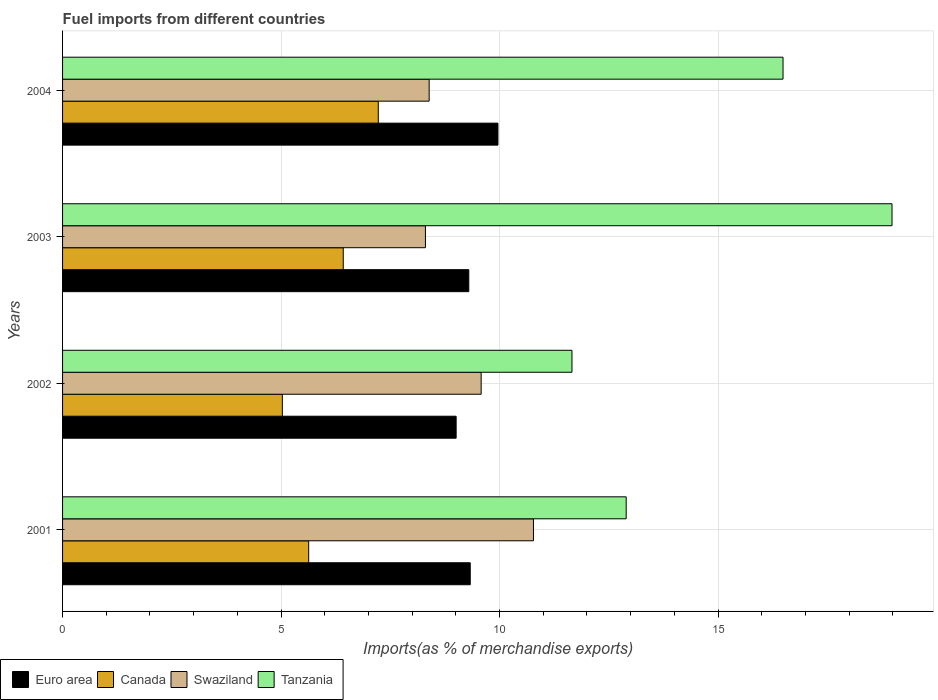How many different coloured bars are there?
Keep it short and to the point. 4. Are the number of bars per tick equal to the number of legend labels?
Your answer should be compact. Yes. Are the number of bars on each tick of the Y-axis equal?
Keep it short and to the point. Yes. In how many cases, is the number of bars for a given year not equal to the number of legend labels?
Offer a very short reply. 0. What is the percentage of imports to different countries in Euro area in 2001?
Your answer should be compact. 9.33. Across all years, what is the maximum percentage of imports to different countries in Canada?
Offer a very short reply. 7.22. Across all years, what is the minimum percentage of imports to different countries in Tanzania?
Give a very brief answer. 11.66. In which year was the percentage of imports to different countries in Canada maximum?
Keep it short and to the point. 2004. In which year was the percentage of imports to different countries in Tanzania minimum?
Offer a very short reply. 2002. What is the total percentage of imports to different countries in Canada in the graph?
Make the answer very short. 24.31. What is the difference between the percentage of imports to different countries in Canada in 2003 and that in 2004?
Make the answer very short. -0.8. What is the difference between the percentage of imports to different countries in Swaziland in 2004 and the percentage of imports to different countries in Euro area in 2003?
Your answer should be very brief. -0.91. What is the average percentage of imports to different countries in Tanzania per year?
Keep it short and to the point. 15.01. In the year 2004, what is the difference between the percentage of imports to different countries in Canada and percentage of imports to different countries in Euro area?
Ensure brevity in your answer.  -2.74. What is the ratio of the percentage of imports to different countries in Canada in 2002 to that in 2004?
Offer a very short reply. 0.7. Is the difference between the percentage of imports to different countries in Canada in 2003 and 2004 greater than the difference between the percentage of imports to different countries in Euro area in 2003 and 2004?
Keep it short and to the point. No. What is the difference between the highest and the second highest percentage of imports to different countries in Tanzania?
Keep it short and to the point. 2.49. What is the difference between the highest and the lowest percentage of imports to different countries in Tanzania?
Provide a succinct answer. 7.32. What does the 3rd bar from the top in 2001 represents?
Make the answer very short. Canada. What does the 4th bar from the bottom in 2002 represents?
Your answer should be very brief. Tanzania. How many bars are there?
Keep it short and to the point. 16. Does the graph contain grids?
Make the answer very short. Yes. Where does the legend appear in the graph?
Keep it short and to the point. Bottom left. How many legend labels are there?
Offer a terse response. 4. How are the legend labels stacked?
Offer a terse response. Horizontal. What is the title of the graph?
Your answer should be very brief. Fuel imports from different countries. What is the label or title of the X-axis?
Make the answer very short. Imports(as % of merchandise exports). What is the label or title of the Y-axis?
Give a very brief answer. Years. What is the Imports(as % of merchandise exports) of Euro area in 2001?
Your answer should be compact. 9.33. What is the Imports(as % of merchandise exports) of Canada in 2001?
Your answer should be compact. 5.63. What is the Imports(as % of merchandise exports) in Swaziland in 2001?
Your response must be concise. 10.78. What is the Imports(as % of merchandise exports) in Tanzania in 2001?
Provide a short and direct response. 12.9. What is the Imports(as % of merchandise exports) in Euro area in 2002?
Keep it short and to the point. 9.01. What is the Imports(as % of merchandise exports) of Canada in 2002?
Provide a succinct answer. 5.03. What is the Imports(as % of merchandise exports) of Swaziland in 2002?
Give a very brief answer. 9.58. What is the Imports(as % of merchandise exports) of Tanzania in 2002?
Provide a short and direct response. 11.66. What is the Imports(as % of merchandise exports) of Euro area in 2003?
Your answer should be very brief. 9.3. What is the Imports(as % of merchandise exports) of Canada in 2003?
Offer a very short reply. 6.42. What is the Imports(as % of merchandise exports) in Swaziland in 2003?
Give a very brief answer. 8.3. What is the Imports(as % of merchandise exports) of Tanzania in 2003?
Offer a very short reply. 18.98. What is the Imports(as % of merchandise exports) of Euro area in 2004?
Keep it short and to the point. 9.96. What is the Imports(as % of merchandise exports) in Canada in 2004?
Your answer should be very brief. 7.22. What is the Imports(as % of merchandise exports) of Swaziland in 2004?
Offer a terse response. 8.39. What is the Imports(as % of merchandise exports) of Tanzania in 2004?
Offer a very short reply. 16.49. Across all years, what is the maximum Imports(as % of merchandise exports) in Euro area?
Provide a succinct answer. 9.96. Across all years, what is the maximum Imports(as % of merchandise exports) in Canada?
Provide a short and direct response. 7.22. Across all years, what is the maximum Imports(as % of merchandise exports) of Swaziland?
Keep it short and to the point. 10.78. Across all years, what is the maximum Imports(as % of merchandise exports) of Tanzania?
Offer a terse response. 18.98. Across all years, what is the minimum Imports(as % of merchandise exports) of Euro area?
Ensure brevity in your answer.  9.01. Across all years, what is the minimum Imports(as % of merchandise exports) of Canada?
Ensure brevity in your answer.  5.03. Across all years, what is the minimum Imports(as % of merchandise exports) in Swaziland?
Ensure brevity in your answer.  8.3. Across all years, what is the minimum Imports(as % of merchandise exports) of Tanzania?
Your answer should be compact. 11.66. What is the total Imports(as % of merchandise exports) of Euro area in the graph?
Ensure brevity in your answer.  37.59. What is the total Imports(as % of merchandise exports) of Canada in the graph?
Offer a terse response. 24.31. What is the total Imports(as % of merchandise exports) in Swaziland in the graph?
Provide a succinct answer. 37.05. What is the total Imports(as % of merchandise exports) of Tanzania in the graph?
Provide a short and direct response. 60.02. What is the difference between the Imports(as % of merchandise exports) in Euro area in 2001 and that in 2002?
Your answer should be very brief. 0.32. What is the difference between the Imports(as % of merchandise exports) in Canada in 2001 and that in 2002?
Make the answer very short. 0.6. What is the difference between the Imports(as % of merchandise exports) of Swaziland in 2001 and that in 2002?
Make the answer very short. 1.2. What is the difference between the Imports(as % of merchandise exports) of Tanzania in 2001 and that in 2002?
Offer a terse response. 1.24. What is the difference between the Imports(as % of merchandise exports) of Euro area in 2001 and that in 2003?
Your response must be concise. 0.03. What is the difference between the Imports(as % of merchandise exports) of Canada in 2001 and that in 2003?
Keep it short and to the point. -0.79. What is the difference between the Imports(as % of merchandise exports) in Swaziland in 2001 and that in 2003?
Keep it short and to the point. 2.47. What is the difference between the Imports(as % of merchandise exports) in Tanzania in 2001 and that in 2003?
Provide a short and direct response. -6.08. What is the difference between the Imports(as % of merchandise exports) in Euro area in 2001 and that in 2004?
Your answer should be very brief. -0.63. What is the difference between the Imports(as % of merchandise exports) in Canada in 2001 and that in 2004?
Keep it short and to the point. -1.59. What is the difference between the Imports(as % of merchandise exports) in Swaziland in 2001 and that in 2004?
Give a very brief answer. 2.39. What is the difference between the Imports(as % of merchandise exports) of Tanzania in 2001 and that in 2004?
Keep it short and to the point. -3.59. What is the difference between the Imports(as % of merchandise exports) in Euro area in 2002 and that in 2003?
Provide a short and direct response. -0.29. What is the difference between the Imports(as % of merchandise exports) of Canada in 2002 and that in 2003?
Give a very brief answer. -1.39. What is the difference between the Imports(as % of merchandise exports) of Swaziland in 2002 and that in 2003?
Provide a short and direct response. 1.28. What is the difference between the Imports(as % of merchandise exports) in Tanzania in 2002 and that in 2003?
Provide a short and direct response. -7.32. What is the difference between the Imports(as % of merchandise exports) in Euro area in 2002 and that in 2004?
Your answer should be very brief. -0.96. What is the difference between the Imports(as % of merchandise exports) in Canada in 2002 and that in 2004?
Provide a succinct answer. -2.2. What is the difference between the Imports(as % of merchandise exports) of Swaziland in 2002 and that in 2004?
Offer a terse response. 1.19. What is the difference between the Imports(as % of merchandise exports) of Tanzania in 2002 and that in 2004?
Give a very brief answer. -4.83. What is the difference between the Imports(as % of merchandise exports) of Euro area in 2003 and that in 2004?
Offer a terse response. -0.67. What is the difference between the Imports(as % of merchandise exports) in Canada in 2003 and that in 2004?
Offer a terse response. -0.8. What is the difference between the Imports(as % of merchandise exports) in Swaziland in 2003 and that in 2004?
Offer a very short reply. -0.09. What is the difference between the Imports(as % of merchandise exports) of Tanzania in 2003 and that in 2004?
Your answer should be very brief. 2.49. What is the difference between the Imports(as % of merchandise exports) in Euro area in 2001 and the Imports(as % of merchandise exports) in Canada in 2002?
Your response must be concise. 4.3. What is the difference between the Imports(as % of merchandise exports) in Euro area in 2001 and the Imports(as % of merchandise exports) in Swaziland in 2002?
Offer a terse response. -0.25. What is the difference between the Imports(as % of merchandise exports) in Euro area in 2001 and the Imports(as % of merchandise exports) in Tanzania in 2002?
Your answer should be compact. -2.33. What is the difference between the Imports(as % of merchandise exports) of Canada in 2001 and the Imports(as % of merchandise exports) of Swaziland in 2002?
Keep it short and to the point. -3.95. What is the difference between the Imports(as % of merchandise exports) in Canada in 2001 and the Imports(as % of merchandise exports) in Tanzania in 2002?
Provide a short and direct response. -6.02. What is the difference between the Imports(as % of merchandise exports) of Swaziland in 2001 and the Imports(as % of merchandise exports) of Tanzania in 2002?
Your answer should be compact. -0.88. What is the difference between the Imports(as % of merchandise exports) in Euro area in 2001 and the Imports(as % of merchandise exports) in Canada in 2003?
Your answer should be very brief. 2.91. What is the difference between the Imports(as % of merchandise exports) of Euro area in 2001 and the Imports(as % of merchandise exports) of Swaziland in 2003?
Your answer should be compact. 1.02. What is the difference between the Imports(as % of merchandise exports) in Euro area in 2001 and the Imports(as % of merchandise exports) in Tanzania in 2003?
Your answer should be very brief. -9.65. What is the difference between the Imports(as % of merchandise exports) in Canada in 2001 and the Imports(as % of merchandise exports) in Swaziland in 2003?
Give a very brief answer. -2.67. What is the difference between the Imports(as % of merchandise exports) of Canada in 2001 and the Imports(as % of merchandise exports) of Tanzania in 2003?
Provide a short and direct response. -13.35. What is the difference between the Imports(as % of merchandise exports) of Swaziland in 2001 and the Imports(as % of merchandise exports) of Tanzania in 2003?
Make the answer very short. -8.2. What is the difference between the Imports(as % of merchandise exports) of Euro area in 2001 and the Imports(as % of merchandise exports) of Canada in 2004?
Your response must be concise. 2.1. What is the difference between the Imports(as % of merchandise exports) of Euro area in 2001 and the Imports(as % of merchandise exports) of Swaziland in 2004?
Provide a short and direct response. 0.94. What is the difference between the Imports(as % of merchandise exports) in Euro area in 2001 and the Imports(as % of merchandise exports) in Tanzania in 2004?
Make the answer very short. -7.16. What is the difference between the Imports(as % of merchandise exports) in Canada in 2001 and the Imports(as % of merchandise exports) in Swaziland in 2004?
Your response must be concise. -2.76. What is the difference between the Imports(as % of merchandise exports) of Canada in 2001 and the Imports(as % of merchandise exports) of Tanzania in 2004?
Give a very brief answer. -10.85. What is the difference between the Imports(as % of merchandise exports) of Swaziland in 2001 and the Imports(as % of merchandise exports) of Tanzania in 2004?
Ensure brevity in your answer.  -5.71. What is the difference between the Imports(as % of merchandise exports) of Euro area in 2002 and the Imports(as % of merchandise exports) of Canada in 2003?
Ensure brevity in your answer.  2.58. What is the difference between the Imports(as % of merchandise exports) of Euro area in 2002 and the Imports(as % of merchandise exports) of Swaziland in 2003?
Provide a succinct answer. 0.7. What is the difference between the Imports(as % of merchandise exports) in Euro area in 2002 and the Imports(as % of merchandise exports) in Tanzania in 2003?
Provide a succinct answer. -9.97. What is the difference between the Imports(as % of merchandise exports) in Canada in 2002 and the Imports(as % of merchandise exports) in Swaziland in 2003?
Ensure brevity in your answer.  -3.27. What is the difference between the Imports(as % of merchandise exports) of Canada in 2002 and the Imports(as % of merchandise exports) of Tanzania in 2003?
Your answer should be very brief. -13.95. What is the difference between the Imports(as % of merchandise exports) of Swaziland in 2002 and the Imports(as % of merchandise exports) of Tanzania in 2003?
Ensure brevity in your answer.  -9.4. What is the difference between the Imports(as % of merchandise exports) in Euro area in 2002 and the Imports(as % of merchandise exports) in Canada in 2004?
Make the answer very short. 1.78. What is the difference between the Imports(as % of merchandise exports) of Euro area in 2002 and the Imports(as % of merchandise exports) of Swaziland in 2004?
Your response must be concise. 0.62. What is the difference between the Imports(as % of merchandise exports) in Euro area in 2002 and the Imports(as % of merchandise exports) in Tanzania in 2004?
Ensure brevity in your answer.  -7.48. What is the difference between the Imports(as % of merchandise exports) of Canada in 2002 and the Imports(as % of merchandise exports) of Swaziland in 2004?
Offer a terse response. -3.36. What is the difference between the Imports(as % of merchandise exports) of Canada in 2002 and the Imports(as % of merchandise exports) of Tanzania in 2004?
Provide a succinct answer. -11.46. What is the difference between the Imports(as % of merchandise exports) in Swaziland in 2002 and the Imports(as % of merchandise exports) in Tanzania in 2004?
Provide a short and direct response. -6.91. What is the difference between the Imports(as % of merchandise exports) in Euro area in 2003 and the Imports(as % of merchandise exports) in Canada in 2004?
Keep it short and to the point. 2.07. What is the difference between the Imports(as % of merchandise exports) in Euro area in 2003 and the Imports(as % of merchandise exports) in Swaziland in 2004?
Your answer should be compact. 0.91. What is the difference between the Imports(as % of merchandise exports) of Euro area in 2003 and the Imports(as % of merchandise exports) of Tanzania in 2004?
Your answer should be compact. -7.19. What is the difference between the Imports(as % of merchandise exports) in Canada in 2003 and the Imports(as % of merchandise exports) in Swaziland in 2004?
Give a very brief answer. -1.97. What is the difference between the Imports(as % of merchandise exports) in Canada in 2003 and the Imports(as % of merchandise exports) in Tanzania in 2004?
Your answer should be compact. -10.06. What is the difference between the Imports(as % of merchandise exports) in Swaziland in 2003 and the Imports(as % of merchandise exports) in Tanzania in 2004?
Provide a short and direct response. -8.18. What is the average Imports(as % of merchandise exports) in Euro area per year?
Your answer should be very brief. 9.4. What is the average Imports(as % of merchandise exports) of Canada per year?
Make the answer very short. 6.08. What is the average Imports(as % of merchandise exports) in Swaziland per year?
Offer a very short reply. 9.26. What is the average Imports(as % of merchandise exports) in Tanzania per year?
Make the answer very short. 15.01. In the year 2001, what is the difference between the Imports(as % of merchandise exports) in Euro area and Imports(as % of merchandise exports) in Canada?
Provide a succinct answer. 3.7. In the year 2001, what is the difference between the Imports(as % of merchandise exports) of Euro area and Imports(as % of merchandise exports) of Swaziland?
Make the answer very short. -1.45. In the year 2001, what is the difference between the Imports(as % of merchandise exports) in Euro area and Imports(as % of merchandise exports) in Tanzania?
Provide a succinct answer. -3.57. In the year 2001, what is the difference between the Imports(as % of merchandise exports) of Canada and Imports(as % of merchandise exports) of Swaziland?
Ensure brevity in your answer.  -5.14. In the year 2001, what is the difference between the Imports(as % of merchandise exports) of Canada and Imports(as % of merchandise exports) of Tanzania?
Keep it short and to the point. -7.27. In the year 2001, what is the difference between the Imports(as % of merchandise exports) in Swaziland and Imports(as % of merchandise exports) in Tanzania?
Provide a short and direct response. -2.12. In the year 2002, what is the difference between the Imports(as % of merchandise exports) of Euro area and Imports(as % of merchandise exports) of Canada?
Provide a succinct answer. 3.98. In the year 2002, what is the difference between the Imports(as % of merchandise exports) in Euro area and Imports(as % of merchandise exports) in Swaziland?
Your answer should be very brief. -0.57. In the year 2002, what is the difference between the Imports(as % of merchandise exports) of Euro area and Imports(as % of merchandise exports) of Tanzania?
Your answer should be very brief. -2.65. In the year 2002, what is the difference between the Imports(as % of merchandise exports) of Canada and Imports(as % of merchandise exports) of Swaziland?
Offer a terse response. -4.55. In the year 2002, what is the difference between the Imports(as % of merchandise exports) in Canada and Imports(as % of merchandise exports) in Tanzania?
Ensure brevity in your answer.  -6.63. In the year 2002, what is the difference between the Imports(as % of merchandise exports) of Swaziland and Imports(as % of merchandise exports) of Tanzania?
Provide a short and direct response. -2.08. In the year 2003, what is the difference between the Imports(as % of merchandise exports) in Euro area and Imports(as % of merchandise exports) in Canada?
Offer a very short reply. 2.87. In the year 2003, what is the difference between the Imports(as % of merchandise exports) of Euro area and Imports(as % of merchandise exports) of Tanzania?
Ensure brevity in your answer.  -9.68. In the year 2003, what is the difference between the Imports(as % of merchandise exports) in Canada and Imports(as % of merchandise exports) in Swaziland?
Ensure brevity in your answer.  -1.88. In the year 2003, what is the difference between the Imports(as % of merchandise exports) in Canada and Imports(as % of merchandise exports) in Tanzania?
Offer a terse response. -12.56. In the year 2003, what is the difference between the Imports(as % of merchandise exports) of Swaziland and Imports(as % of merchandise exports) of Tanzania?
Your answer should be compact. -10.68. In the year 2004, what is the difference between the Imports(as % of merchandise exports) in Euro area and Imports(as % of merchandise exports) in Canada?
Give a very brief answer. 2.74. In the year 2004, what is the difference between the Imports(as % of merchandise exports) in Euro area and Imports(as % of merchandise exports) in Swaziland?
Provide a short and direct response. 1.57. In the year 2004, what is the difference between the Imports(as % of merchandise exports) of Euro area and Imports(as % of merchandise exports) of Tanzania?
Your answer should be compact. -6.52. In the year 2004, what is the difference between the Imports(as % of merchandise exports) in Canada and Imports(as % of merchandise exports) in Swaziland?
Make the answer very short. -1.16. In the year 2004, what is the difference between the Imports(as % of merchandise exports) of Canada and Imports(as % of merchandise exports) of Tanzania?
Make the answer very short. -9.26. In the year 2004, what is the difference between the Imports(as % of merchandise exports) in Swaziland and Imports(as % of merchandise exports) in Tanzania?
Provide a short and direct response. -8.1. What is the ratio of the Imports(as % of merchandise exports) in Euro area in 2001 to that in 2002?
Ensure brevity in your answer.  1.04. What is the ratio of the Imports(as % of merchandise exports) of Canada in 2001 to that in 2002?
Make the answer very short. 1.12. What is the ratio of the Imports(as % of merchandise exports) of Tanzania in 2001 to that in 2002?
Keep it short and to the point. 1.11. What is the ratio of the Imports(as % of merchandise exports) in Canada in 2001 to that in 2003?
Give a very brief answer. 0.88. What is the ratio of the Imports(as % of merchandise exports) in Swaziland in 2001 to that in 2003?
Your answer should be very brief. 1.3. What is the ratio of the Imports(as % of merchandise exports) of Tanzania in 2001 to that in 2003?
Provide a short and direct response. 0.68. What is the ratio of the Imports(as % of merchandise exports) in Euro area in 2001 to that in 2004?
Your answer should be very brief. 0.94. What is the ratio of the Imports(as % of merchandise exports) of Canada in 2001 to that in 2004?
Make the answer very short. 0.78. What is the ratio of the Imports(as % of merchandise exports) of Swaziland in 2001 to that in 2004?
Offer a very short reply. 1.28. What is the ratio of the Imports(as % of merchandise exports) of Tanzania in 2001 to that in 2004?
Keep it short and to the point. 0.78. What is the ratio of the Imports(as % of merchandise exports) of Euro area in 2002 to that in 2003?
Ensure brevity in your answer.  0.97. What is the ratio of the Imports(as % of merchandise exports) in Canada in 2002 to that in 2003?
Your answer should be compact. 0.78. What is the ratio of the Imports(as % of merchandise exports) of Swaziland in 2002 to that in 2003?
Give a very brief answer. 1.15. What is the ratio of the Imports(as % of merchandise exports) in Tanzania in 2002 to that in 2003?
Provide a succinct answer. 0.61. What is the ratio of the Imports(as % of merchandise exports) of Euro area in 2002 to that in 2004?
Provide a short and direct response. 0.9. What is the ratio of the Imports(as % of merchandise exports) of Canada in 2002 to that in 2004?
Your answer should be compact. 0.7. What is the ratio of the Imports(as % of merchandise exports) of Swaziland in 2002 to that in 2004?
Your answer should be compact. 1.14. What is the ratio of the Imports(as % of merchandise exports) of Tanzania in 2002 to that in 2004?
Keep it short and to the point. 0.71. What is the ratio of the Imports(as % of merchandise exports) in Euro area in 2003 to that in 2004?
Your answer should be compact. 0.93. What is the ratio of the Imports(as % of merchandise exports) in Canada in 2003 to that in 2004?
Provide a succinct answer. 0.89. What is the ratio of the Imports(as % of merchandise exports) in Tanzania in 2003 to that in 2004?
Give a very brief answer. 1.15. What is the difference between the highest and the second highest Imports(as % of merchandise exports) of Euro area?
Keep it short and to the point. 0.63. What is the difference between the highest and the second highest Imports(as % of merchandise exports) in Canada?
Ensure brevity in your answer.  0.8. What is the difference between the highest and the second highest Imports(as % of merchandise exports) of Swaziland?
Provide a succinct answer. 1.2. What is the difference between the highest and the second highest Imports(as % of merchandise exports) of Tanzania?
Your response must be concise. 2.49. What is the difference between the highest and the lowest Imports(as % of merchandise exports) in Euro area?
Your answer should be very brief. 0.96. What is the difference between the highest and the lowest Imports(as % of merchandise exports) in Canada?
Your answer should be very brief. 2.2. What is the difference between the highest and the lowest Imports(as % of merchandise exports) of Swaziland?
Keep it short and to the point. 2.47. What is the difference between the highest and the lowest Imports(as % of merchandise exports) in Tanzania?
Ensure brevity in your answer.  7.32. 